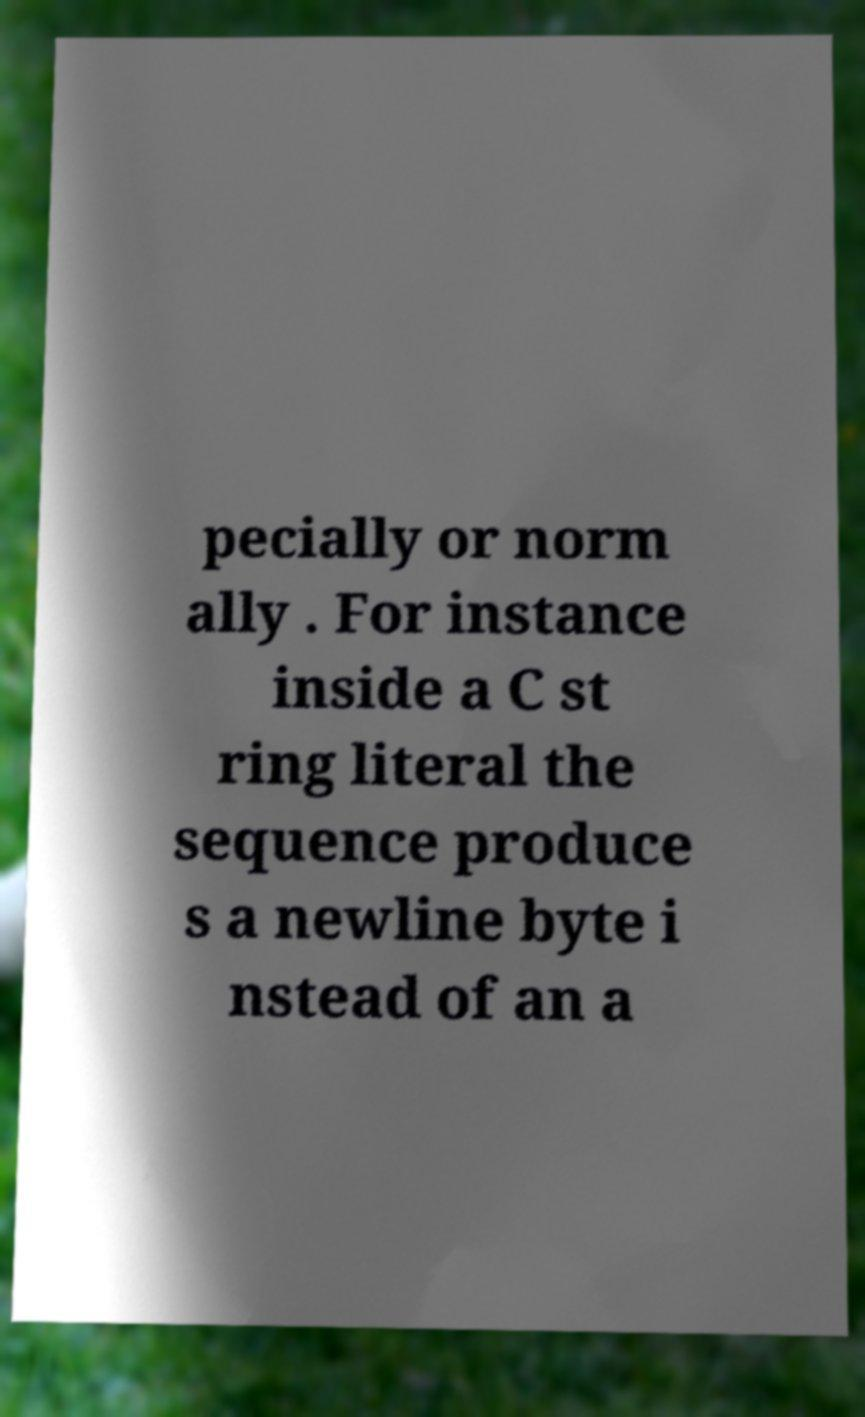Can you read and provide the text displayed in the image?This photo seems to have some interesting text. Can you extract and type it out for me? pecially or norm ally . For instance inside a C st ring literal the sequence produce s a newline byte i nstead of an a 